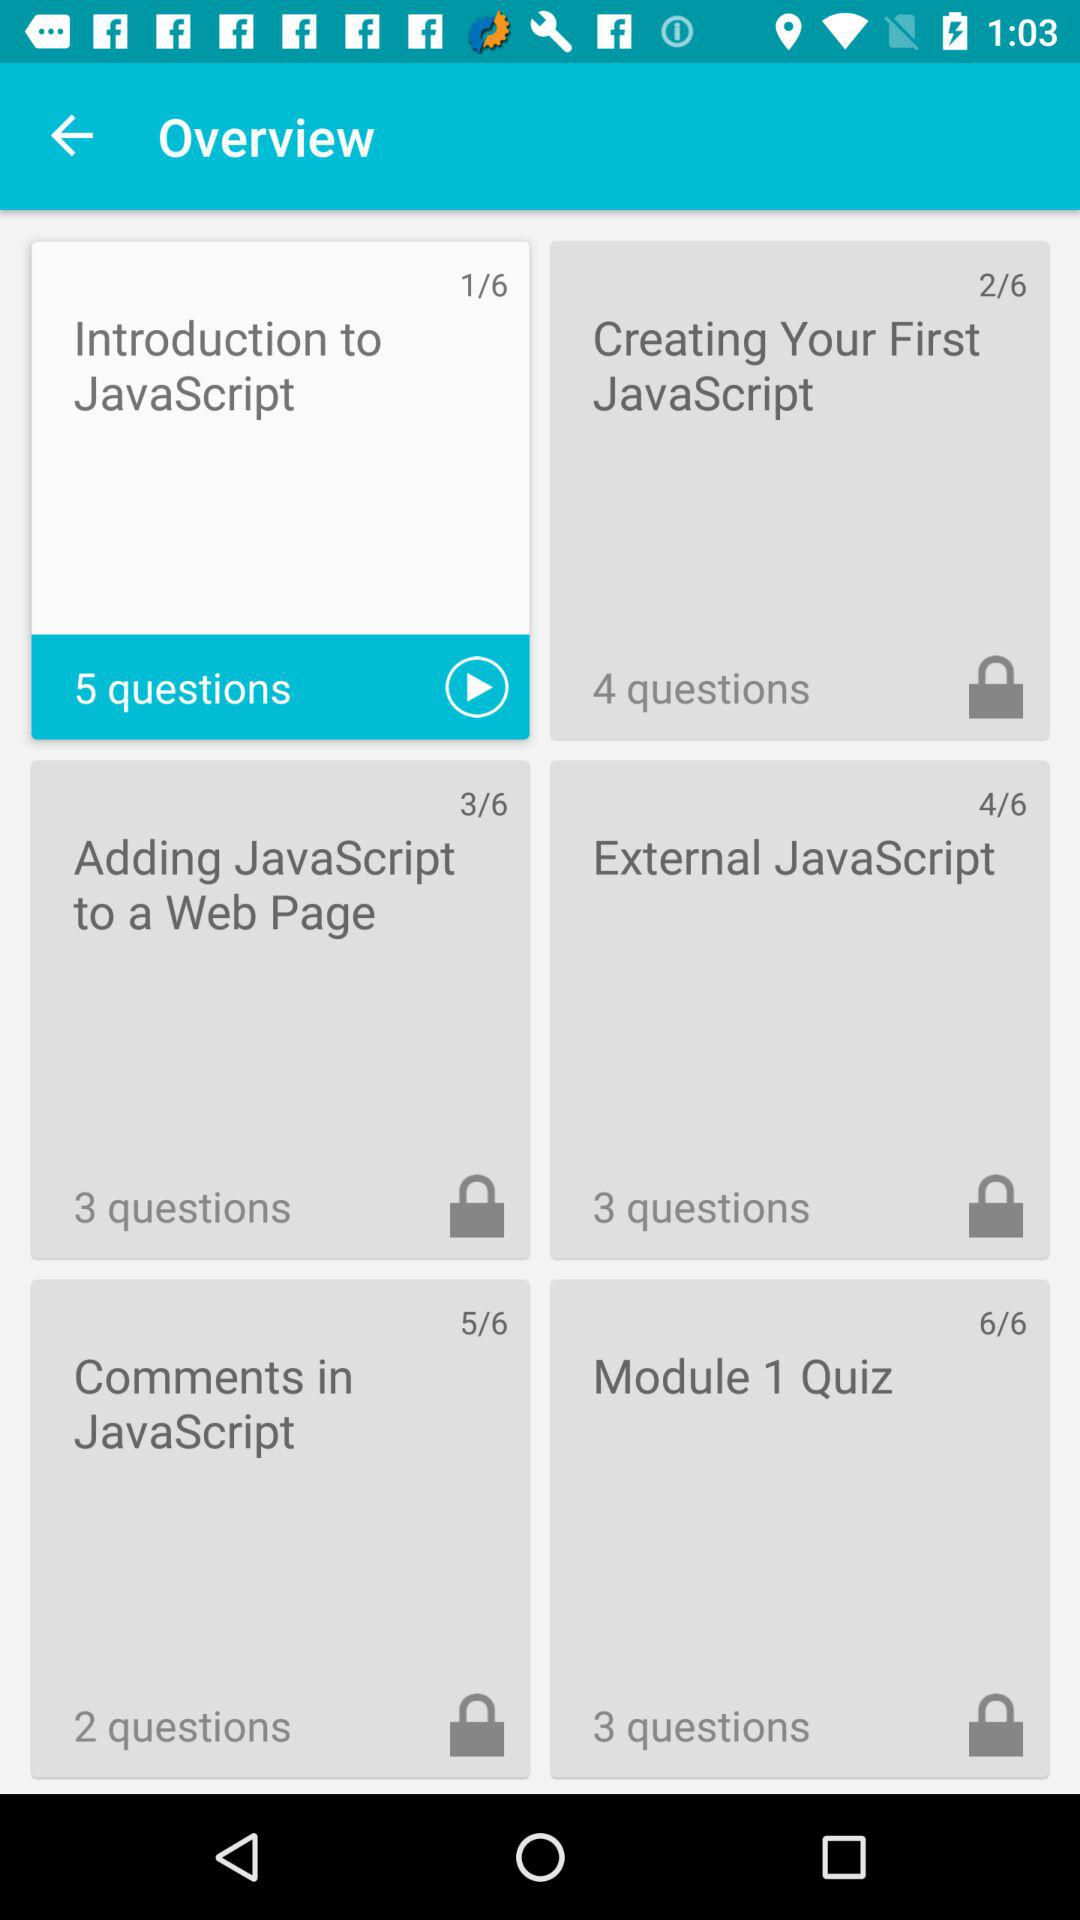What is the number of questions in "Introduction to JavaScript"? There are 5 questions. 